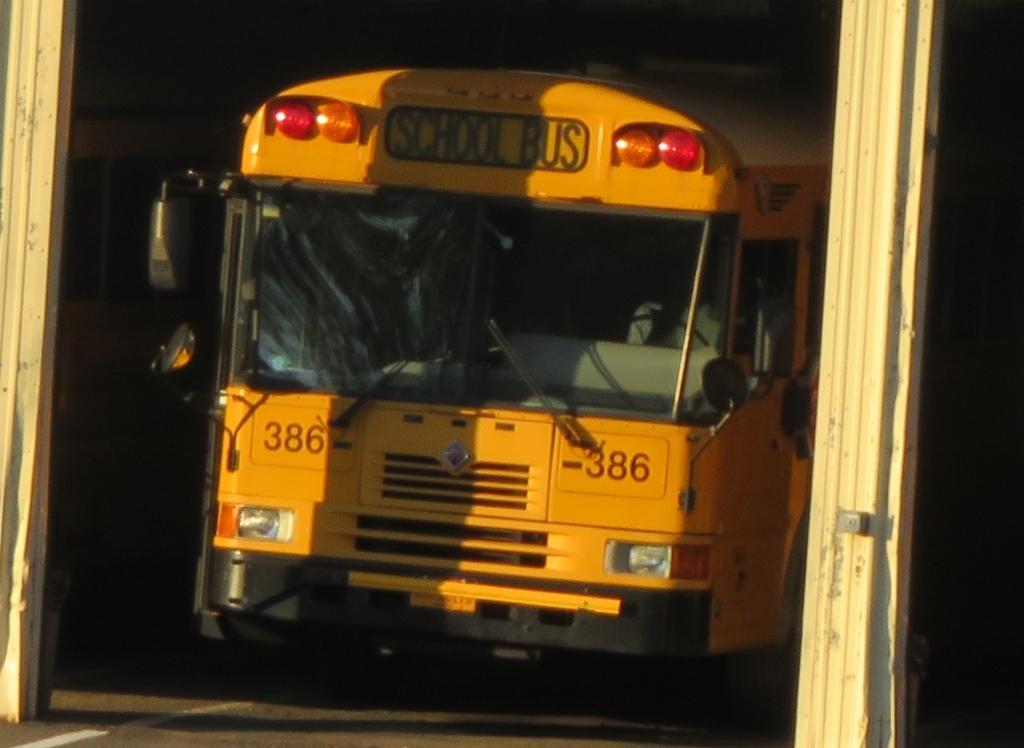Could you give a brief overview of what you see in this image? In this image there is a vehicle. On the right and left side of the vehicle there is a wooden pole. The background is dark. 